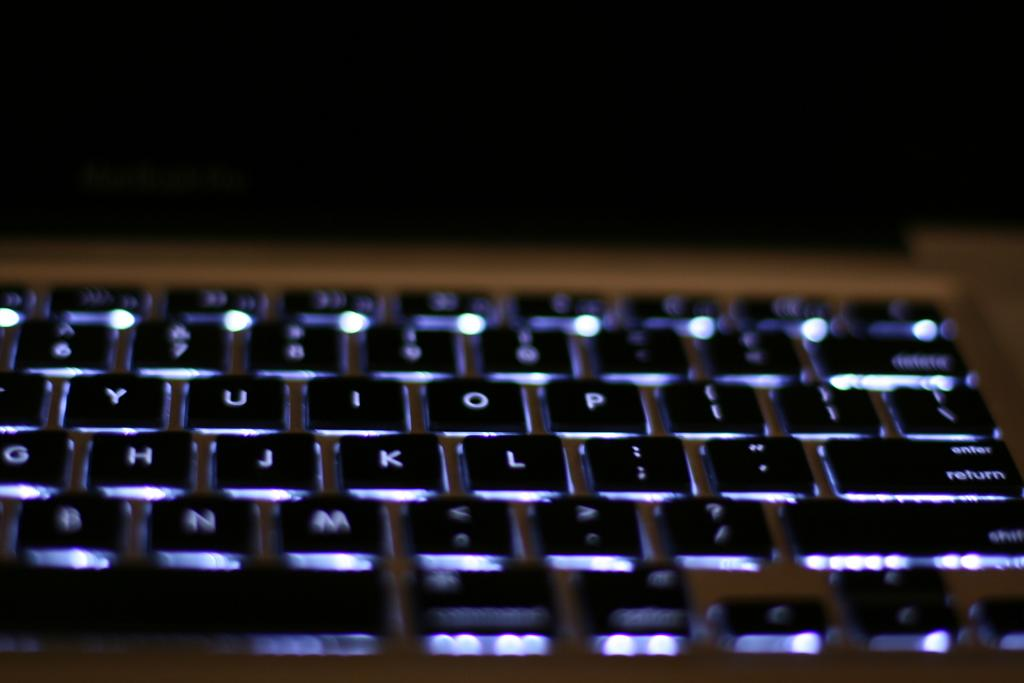<image>
Present a compact description of the photo's key features. Keyboard with alphabet buttons, return button, and shift button 